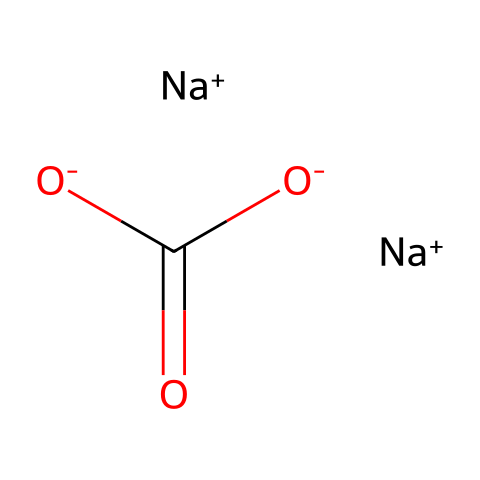What is the name of this chemical? The SMILES provided translates to sodium carbonate, which is commonly known as washing soda. The “Na” indicates sodium ions and the carbonate structure identifies it.
Answer: sodium carbonate How many sodium atoms are present in this molecule? The SMILES shows two instances of “Na+”, indicating there are two sodium atoms.
Answer: 2 What is the charge of the carbonate ion in sodium carbonate? The carbonate ion is expressed as “C(=O)[O-][O-]”, showing two negative charges on the oxygen atoms, resulting in an overall charge of -2.
Answer: -2 What functional group is present in sodium carbonate? The presence of the “C(=O)” section indicates a carbonate group, specifically the presence of a carbon atom double-bonded to one oxygen atom and single-bonded to another two oxygens.
Answer: carbonate group Why is sodium carbonate used as a water softener? Sodium carbonate helps in softening water by binding with calcium and magnesium ions in the water, effectively reducing the hardness. The carbonate ions precipitate these ions out.
Answer: binding with calcium and magnesium How does sodium carbonate affect the pH of a solution? Sodium carbonate can increase the pH of a solution because it reacts with water to produce hydroxide ions, making the solution more alkaline. This property is useful in detergent formulations for stain removal.
Answer: increases pH 